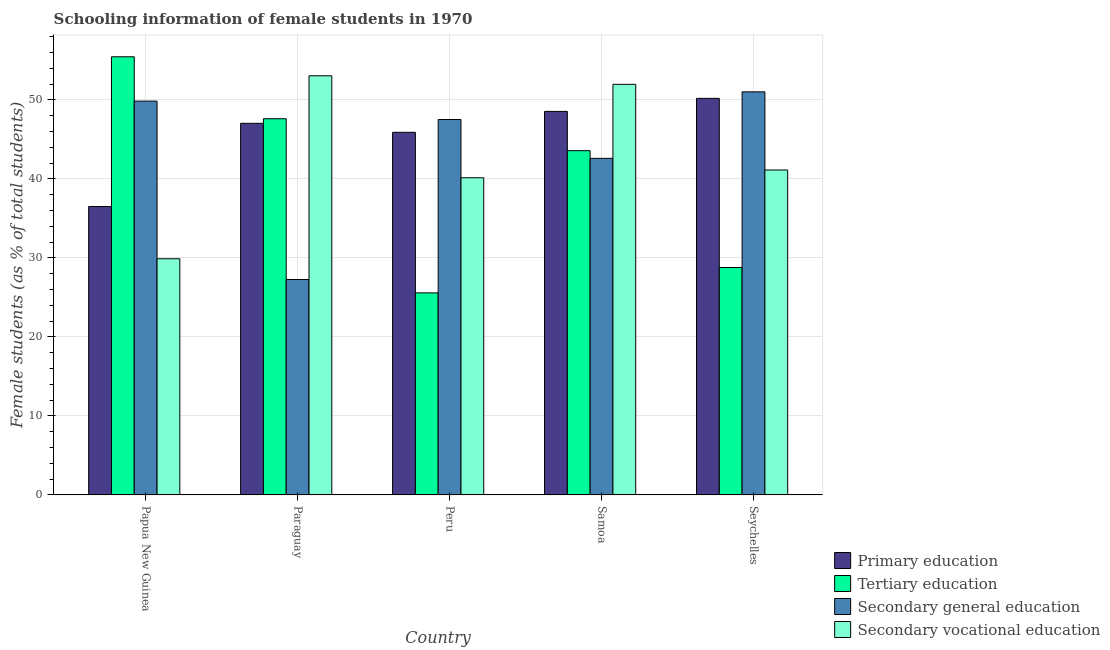How many different coloured bars are there?
Offer a very short reply. 4. Are the number of bars per tick equal to the number of legend labels?
Provide a short and direct response. Yes. Are the number of bars on each tick of the X-axis equal?
Provide a short and direct response. Yes. How many bars are there on the 4th tick from the left?
Provide a succinct answer. 4. What is the label of the 5th group of bars from the left?
Keep it short and to the point. Seychelles. In how many cases, is the number of bars for a given country not equal to the number of legend labels?
Your answer should be very brief. 0. What is the percentage of female students in secondary vocational education in Peru?
Make the answer very short. 40.14. Across all countries, what is the maximum percentage of female students in tertiary education?
Your response must be concise. 55.45. Across all countries, what is the minimum percentage of female students in tertiary education?
Your answer should be compact. 25.57. In which country was the percentage of female students in secondary vocational education maximum?
Offer a very short reply. Paraguay. In which country was the percentage of female students in primary education minimum?
Your answer should be compact. Papua New Guinea. What is the total percentage of female students in primary education in the graph?
Provide a short and direct response. 228.13. What is the difference between the percentage of female students in secondary education in Samoa and that in Seychelles?
Your response must be concise. -8.42. What is the difference between the percentage of female students in tertiary education in Seychelles and the percentage of female students in secondary education in Peru?
Offer a terse response. -18.73. What is the average percentage of female students in secondary vocational education per country?
Provide a short and direct response. 43.23. What is the difference between the percentage of female students in primary education and percentage of female students in secondary education in Seychelles?
Make the answer very short. -0.83. In how many countries, is the percentage of female students in secondary education greater than 56 %?
Offer a very short reply. 0. What is the ratio of the percentage of female students in primary education in Papua New Guinea to that in Paraguay?
Offer a terse response. 0.78. Is the percentage of female students in tertiary education in Papua New Guinea less than that in Paraguay?
Keep it short and to the point. No. What is the difference between the highest and the second highest percentage of female students in primary education?
Provide a succinct answer. 1.65. What is the difference between the highest and the lowest percentage of female students in tertiary education?
Your answer should be very brief. 29.88. In how many countries, is the percentage of female students in secondary education greater than the average percentage of female students in secondary education taken over all countries?
Your answer should be compact. 3. Is it the case that in every country, the sum of the percentage of female students in tertiary education and percentage of female students in secondary education is greater than the sum of percentage of female students in secondary vocational education and percentage of female students in primary education?
Offer a very short reply. Yes. What does the 3rd bar from the left in Peru represents?
Ensure brevity in your answer.  Secondary general education. What does the 3rd bar from the right in Seychelles represents?
Make the answer very short. Tertiary education. Is it the case that in every country, the sum of the percentage of female students in primary education and percentage of female students in tertiary education is greater than the percentage of female students in secondary education?
Keep it short and to the point. Yes. How many bars are there?
Make the answer very short. 20. Are the values on the major ticks of Y-axis written in scientific E-notation?
Your answer should be very brief. No. Does the graph contain any zero values?
Keep it short and to the point. No. Does the graph contain grids?
Provide a succinct answer. Yes. Where does the legend appear in the graph?
Your answer should be very brief. Bottom right. How are the legend labels stacked?
Offer a very short reply. Vertical. What is the title of the graph?
Make the answer very short. Schooling information of female students in 1970. Does "Interest Payments" appear as one of the legend labels in the graph?
Give a very brief answer. No. What is the label or title of the X-axis?
Your answer should be very brief. Country. What is the label or title of the Y-axis?
Your answer should be very brief. Female students (as % of total students). What is the Female students (as % of total students) of Primary education in Papua New Guinea?
Make the answer very short. 36.5. What is the Female students (as % of total students) in Tertiary education in Papua New Guinea?
Offer a very short reply. 55.45. What is the Female students (as % of total students) of Secondary general education in Papua New Guinea?
Provide a succinct answer. 49.84. What is the Female students (as % of total students) of Secondary vocational education in Papua New Guinea?
Your response must be concise. 29.89. What is the Female students (as % of total students) in Primary education in Paraguay?
Offer a very short reply. 47.03. What is the Female students (as % of total students) of Tertiary education in Paraguay?
Your answer should be compact. 47.61. What is the Female students (as % of total students) in Secondary general education in Paraguay?
Offer a very short reply. 27.26. What is the Female students (as % of total students) in Secondary vocational education in Paraguay?
Your answer should be compact. 53.04. What is the Female students (as % of total students) of Primary education in Peru?
Your answer should be very brief. 45.89. What is the Female students (as % of total students) in Tertiary education in Peru?
Keep it short and to the point. 25.57. What is the Female students (as % of total students) in Secondary general education in Peru?
Ensure brevity in your answer.  47.51. What is the Female students (as % of total students) of Secondary vocational education in Peru?
Your response must be concise. 40.14. What is the Female students (as % of total students) in Primary education in Samoa?
Your answer should be very brief. 48.54. What is the Female students (as % of total students) in Tertiary education in Samoa?
Your answer should be very brief. 43.56. What is the Female students (as % of total students) in Secondary general education in Samoa?
Ensure brevity in your answer.  42.59. What is the Female students (as % of total students) of Secondary vocational education in Samoa?
Your answer should be compact. 51.96. What is the Female students (as % of total students) in Primary education in Seychelles?
Provide a succinct answer. 50.18. What is the Female students (as % of total students) in Tertiary education in Seychelles?
Keep it short and to the point. 28.78. What is the Female students (as % of total students) of Secondary general education in Seychelles?
Ensure brevity in your answer.  51.01. What is the Female students (as % of total students) in Secondary vocational education in Seychelles?
Provide a succinct answer. 41.12. Across all countries, what is the maximum Female students (as % of total students) in Primary education?
Your response must be concise. 50.18. Across all countries, what is the maximum Female students (as % of total students) in Tertiary education?
Ensure brevity in your answer.  55.45. Across all countries, what is the maximum Female students (as % of total students) in Secondary general education?
Your answer should be very brief. 51.01. Across all countries, what is the maximum Female students (as % of total students) in Secondary vocational education?
Provide a succinct answer. 53.04. Across all countries, what is the minimum Female students (as % of total students) of Primary education?
Make the answer very short. 36.5. Across all countries, what is the minimum Female students (as % of total students) in Tertiary education?
Your answer should be compact. 25.57. Across all countries, what is the minimum Female students (as % of total students) of Secondary general education?
Keep it short and to the point. 27.26. Across all countries, what is the minimum Female students (as % of total students) in Secondary vocational education?
Ensure brevity in your answer.  29.89. What is the total Female students (as % of total students) in Primary education in the graph?
Ensure brevity in your answer.  228.13. What is the total Female students (as % of total students) of Tertiary education in the graph?
Your answer should be very brief. 200.97. What is the total Female students (as % of total students) of Secondary general education in the graph?
Offer a terse response. 218.21. What is the total Female students (as % of total students) in Secondary vocational education in the graph?
Offer a very short reply. 216.15. What is the difference between the Female students (as % of total students) of Primary education in Papua New Guinea and that in Paraguay?
Keep it short and to the point. -10.53. What is the difference between the Female students (as % of total students) of Tertiary education in Papua New Guinea and that in Paraguay?
Provide a succinct answer. 7.84. What is the difference between the Female students (as % of total students) in Secondary general education in Papua New Guinea and that in Paraguay?
Make the answer very short. 22.57. What is the difference between the Female students (as % of total students) of Secondary vocational education in Papua New Guinea and that in Paraguay?
Offer a very short reply. -23.15. What is the difference between the Female students (as % of total students) of Primary education in Papua New Guinea and that in Peru?
Your response must be concise. -9.39. What is the difference between the Female students (as % of total students) in Tertiary education in Papua New Guinea and that in Peru?
Make the answer very short. 29.88. What is the difference between the Female students (as % of total students) in Secondary general education in Papua New Guinea and that in Peru?
Keep it short and to the point. 2.33. What is the difference between the Female students (as % of total students) in Secondary vocational education in Papua New Guinea and that in Peru?
Make the answer very short. -10.25. What is the difference between the Female students (as % of total students) in Primary education in Papua New Guinea and that in Samoa?
Your answer should be very brief. -12.04. What is the difference between the Female students (as % of total students) in Tertiary education in Papua New Guinea and that in Samoa?
Your answer should be compact. 11.88. What is the difference between the Female students (as % of total students) of Secondary general education in Papua New Guinea and that in Samoa?
Provide a short and direct response. 7.24. What is the difference between the Female students (as % of total students) in Secondary vocational education in Papua New Guinea and that in Samoa?
Make the answer very short. -22.07. What is the difference between the Female students (as % of total students) in Primary education in Papua New Guinea and that in Seychelles?
Your answer should be very brief. -13.69. What is the difference between the Female students (as % of total students) of Tertiary education in Papua New Guinea and that in Seychelles?
Ensure brevity in your answer.  26.67. What is the difference between the Female students (as % of total students) in Secondary general education in Papua New Guinea and that in Seychelles?
Ensure brevity in your answer.  -1.17. What is the difference between the Female students (as % of total students) in Secondary vocational education in Papua New Guinea and that in Seychelles?
Offer a very short reply. -11.23. What is the difference between the Female students (as % of total students) in Primary education in Paraguay and that in Peru?
Offer a very short reply. 1.14. What is the difference between the Female students (as % of total students) in Tertiary education in Paraguay and that in Peru?
Provide a short and direct response. 22.04. What is the difference between the Female students (as % of total students) of Secondary general education in Paraguay and that in Peru?
Provide a short and direct response. -20.24. What is the difference between the Female students (as % of total students) of Secondary vocational education in Paraguay and that in Peru?
Keep it short and to the point. 12.9. What is the difference between the Female students (as % of total students) of Primary education in Paraguay and that in Samoa?
Give a very brief answer. -1.51. What is the difference between the Female students (as % of total students) in Tertiary education in Paraguay and that in Samoa?
Ensure brevity in your answer.  4.04. What is the difference between the Female students (as % of total students) of Secondary general education in Paraguay and that in Samoa?
Your response must be concise. -15.33. What is the difference between the Female students (as % of total students) of Secondary vocational education in Paraguay and that in Samoa?
Offer a very short reply. 1.08. What is the difference between the Female students (as % of total students) in Primary education in Paraguay and that in Seychelles?
Your answer should be compact. -3.16. What is the difference between the Female students (as % of total students) of Tertiary education in Paraguay and that in Seychelles?
Give a very brief answer. 18.83. What is the difference between the Female students (as % of total students) of Secondary general education in Paraguay and that in Seychelles?
Give a very brief answer. -23.75. What is the difference between the Female students (as % of total students) in Secondary vocational education in Paraguay and that in Seychelles?
Offer a very short reply. 11.92. What is the difference between the Female students (as % of total students) in Primary education in Peru and that in Samoa?
Ensure brevity in your answer.  -2.65. What is the difference between the Female students (as % of total students) of Tertiary education in Peru and that in Samoa?
Your response must be concise. -17.99. What is the difference between the Female students (as % of total students) in Secondary general education in Peru and that in Samoa?
Provide a succinct answer. 4.92. What is the difference between the Female students (as % of total students) of Secondary vocational education in Peru and that in Samoa?
Provide a short and direct response. -11.82. What is the difference between the Female students (as % of total students) of Primary education in Peru and that in Seychelles?
Provide a short and direct response. -4.29. What is the difference between the Female students (as % of total students) in Tertiary education in Peru and that in Seychelles?
Keep it short and to the point. -3.21. What is the difference between the Female students (as % of total students) of Secondary general education in Peru and that in Seychelles?
Ensure brevity in your answer.  -3.5. What is the difference between the Female students (as % of total students) of Secondary vocational education in Peru and that in Seychelles?
Your response must be concise. -0.98. What is the difference between the Female students (as % of total students) of Primary education in Samoa and that in Seychelles?
Make the answer very short. -1.65. What is the difference between the Female students (as % of total students) in Tertiary education in Samoa and that in Seychelles?
Keep it short and to the point. 14.78. What is the difference between the Female students (as % of total students) of Secondary general education in Samoa and that in Seychelles?
Provide a short and direct response. -8.42. What is the difference between the Female students (as % of total students) of Secondary vocational education in Samoa and that in Seychelles?
Your answer should be compact. 10.84. What is the difference between the Female students (as % of total students) of Primary education in Papua New Guinea and the Female students (as % of total students) of Tertiary education in Paraguay?
Your answer should be compact. -11.11. What is the difference between the Female students (as % of total students) of Primary education in Papua New Guinea and the Female students (as % of total students) of Secondary general education in Paraguay?
Your answer should be compact. 9.23. What is the difference between the Female students (as % of total students) of Primary education in Papua New Guinea and the Female students (as % of total students) of Secondary vocational education in Paraguay?
Your answer should be very brief. -16.54. What is the difference between the Female students (as % of total students) in Tertiary education in Papua New Guinea and the Female students (as % of total students) in Secondary general education in Paraguay?
Your answer should be very brief. 28.18. What is the difference between the Female students (as % of total students) in Tertiary education in Papua New Guinea and the Female students (as % of total students) in Secondary vocational education in Paraguay?
Your answer should be very brief. 2.41. What is the difference between the Female students (as % of total students) in Secondary general education in Papua New Guinea and the Female students (as % of total students) in Secondary vocational education in Paraguay?
Keep it short and to the point. -3.2. What is the difference between the Female students (as % of total students) in Primary education in Papua New Guinea and the Female students (as % of total students) in Tertiary education in Peru?
Your answer should be compact. 10.93. What is the difference between the Female students (as % of total students) of Primary education in Papua New Guinea and the Female students (as % of total students) of Secondary general education in Peru?
Provide a short and direct response. -11.01. What is the difference between the Female students (as % of total students) in Primary education in Papua New Guinea and the Female students (as % of total students) in Secondary vocational education in Peru?
Offer a very short reply. -3.64. What is the difference between the Female students (as % of total students) in Tertiary education in Papua New Guinea and the Female students (as % of total students) in Secondary general education in Peru?
Give a very brief answer. 7.94. What is the difference between the Female students (as % of total students) of Tertiary education in Papua New Guinea and the Female students (as % of total students) of Secondary vocational education in Peru?
Your response must be concise. 15.31. What is the difference between the Female students (as % of total students) of Secondary general education in Papua New Guinea and the Female students (as % of total students) of Secondary vocational education in Peru?
Make the answer very short. 9.7. What is the difference between the Female students (as % of total students) of Primary education in Papua New Guinea and the Female students (as % of total students) of Tertiary education in Samoa?
Offer a terse response. -7.07. What is the difference between the Female students (as % of total students) in Primary education in Papua New Guinea and the Female students (as % of total students) in Secondary general education in Samoa?
Keep it short and to the point. -6.1. What is the difference between the Female students (as % of total students) of Primary education in Papua New Guinea and the Female students (as % of total students) of Secondary vocational education in Samoa?
Give a very brief answer. -15.46. What is the difference between the Female students (as % of total students) of Tertiary education in Papua New Guinea and the Female students (as % of total students) of Secondary general education in Samoa?
Offer a terse response. 12.85. What is the difference between the Female students (as % of total students) in Tertiary education in Papua New Guinea and the Female students (as % of total students) in Secondary vocational education in Samoa?
Provide a succinct answer. 3.49. What is the difference between the Female students (as % of total students) of Secondary general education in Papua New Guinea and the Female students (as % of total students) of Secondary vocational education in Samoa?
Give a very brief answer. -2.12. What is the difference between the Female students (as % of total students) of Primary education in Papua New Guinea and the Female students (as % of total students) of Tertiary education in Seychelles?
Provide a succinct answer. 7.72. What is the difference between the Female students (as % of total students) in Primary education in Papua New Guinea and the Female students (as % of total students) in Secondary general education in Seychelles?
Give a very brief answer. -14.51. What is the difference between the Female students (as % of total students) of Primary education in Papua New Guinea and the Female students (as % of total students) of Secondary vocational education in Seychelles?
Provide a short and direct response. -4.62. What is the difference between the Female students (as % of total students) in Tertiary education in Papua New Guinea and the Female students (as % of total students) in Secondary general education in Seychelles?
Provide a succinct answer. 4.44. What is the difference between the Female students (as % of total students) of Tertiary education in Papua New Guinea and the Female students (as % of total students) of Secondary vocational education in Seychelles?
Your response must be concise. 14.33. What is the difference between the Female students (as % of total students) of Secondary general education in Papua New Guinea and the Female students (as % of total students) of Secondary vocational education in Seychelles?
Your answer should be compact. 8.72. What is the difference between the Female students (as % of total students) in Primary education in Paraguay and the Female students (as % of total students) in Tertiary education in Peru?
Provide a short and direct response. 21.46. What is the difference between the Female students (as % of total students) in Primary education in Paraguay and the Female students (as % of total students) in Secondary general education in Peru?
Offer a very short reply. -0.48. What is the difference between the Female students (as % of total students) of Primary education in Paraguay and the Female students (as % of total students) of Secondary vocational education in Peru?
Your response must be concise. 6.89. What is the difference between the Female students (as % of total students) in Tertiary education in Paraguay and the Female students (as % of total students) in Secondary general education in Peru?
Provide a succinct answer. 0.1. What is the difference between the Female students (as % of total students) of Tertiary education in Paraguay and the Female students (as % of total students) of Secondary vocational education in Peru?
Your response must be concise. 7.47. What is the difference between the Female students (as % of total students) in Secondary general education in Paraguay and the Female students (as % of total students) in Secondary vocational education in Peru?
Make the answer very short. -12.87. What is the difference between the Female students (as % of total students) of Primary education in Paraguay and the Female students (as % of total students) of Tertiary education in Samoa?
Provide a succinct answer. 3.46. What is the difference between the Female students (as % of total students) in Primary education in Paraguay and the Female students (as % of total students) in Secondary general education in Samoa?
Your response must be concise. 4.43. What is the difference between the Female students (as % of total students) of Primary education in Paraguay and the Female students (as % of total students) of Secondary vocational education in Samoa?
Provide a short and direct response. -4.93. What is the difference between the Female students (as % of total students) of Tertiary education in Paraguay and the Female students (as % of total students) of Secondary general education in Samoa?
Ensure brevity in your answer.  5.02. What is the difference between the Female students (as % of total students) of Tertiary education in Paraguay and the Female students (as % of total students) of Secondary vocational education in Samoa?
Offer a very short reply. -4.35. What is the difference between the Female students (as % of total students) in Secondary general education in Paraguay and the Female students (as % of total students) in Secondary vocational education in Samoa?
Ensure brevity in your answer.  -24.7. What is the difference between the Female students (as % of total students) in Primary education in Paraguay and the Female students (as % of total students) in Tertiary education in Seychelles?
Your answer should be very brief. 18.25. What is the difference between the Female students (as % of total students) in Primary education in Paraguay and the Female students (as % of total students) in Secondary general education in Seychelles?
Offer a terse response. -3.98. What is the difference between the Female students (as % of total students) of Primary education in Paraguay and the Female students (as % of total students) of Secondary vocational education in Seychelles?
Provide a succinct answer. 5.91. What is the difference between the Female students (as % of total students) in Tertiary education in Paraguay and the Female students (as % of total students) in Secondary general education in Seychelles?
Offer a terse response. -3.4. What is the difference between the Female students (as % of total students) of Tertiary education in Paraguay and the Female students (as % of total students) of Secondary vocational education in Seychelles?
Your answer should be very brief. 6.49. What is the difference between the Female students (as % of total students) of Secondary general education in Paraguay and the Female students (as % of total students) of Secondary vocational education in Seychelles?
Keep it short and to the point. -13.86. What is the difference between the Female students (as % of total students) in Primary education in Peru and the Female students (as % of total students) in Tertiary education in Samoa?
Your answer should be very brief. 2.32. What is the difference between the Female students (as % of total students) in Primary education in Peru and the Female students (as % of total students) in Secondary general education in Samoa?
Provide a succinct answer. 3.3. What is the difference between the Female students (as % of total students) in Primary education in Peru and the Female students (as % of total students) in Secondary vocational education in Samoa?
Your response must be concise. -6.07. What is the difference between the Female students (as % of total students) of Tertiary education in Peru and the Female students (as % of total students) of Secondary general education in Samoa?
Your answer should be very brief. -17.02. What is the difference between the Female students (as % of total students) in Tertiary education in Peru and the Female students (as % of total students) in Secondary vocational education in Samoa?
Provide a short and direct response. -26.39. What is the difference between the Female students (as % of total students) of Secondary general education in Peru and the Female students (as % of total students) of Secondary vocational education in Samoa?
Offer a very short reply. -4.45. What is the difference between the Female students (as % of total students) of Primary education in Peru and the Female students (as % of total students) of Tertiary education in Seychelles?
Provide a succinct answer. 17.11. What is the difference between the Female students (as % of total students) in Primary education in Peru and the Female students (as % of total students) in Secondary general education in Seychelles?
Ensure brevity in your answer.  -5.12. What is the difference between the Female students (as % of total students) of Primary education in Peru and the Female students (as % of total students) of Secondary vocational education in Seychelles?
Offer a very short reply. 4.77. What is the difference between the Female students (as % of total students) in Tertiary education in Peru and the Female students (as % of total students) in Secondary general education in Seychelles?
Keep it short and to the point. -25.44. What is the difference between the Female students (as % of total students) in Tertiary education in Peru and the Female students (as % of total students) in Secondary vocational education in Seychelles?
Ensure brevity in your answer.  -15.55. What is the difference between the Female students (as % of total students) of Secondary general education in Peru and the Female students (as % of total students) of Secondary vocational education in Seychelles?
Offer a terse response. 6.39. What is the difference between the Female students (as % of total students) in Primary education in Samoa and the Female students (as % of total students) in Tertiary education in Seychelles?
Keep it short and to the point. 19.76. What is the difference between the Female students (as % of total students) in Primary education in Samoa and the Female students (as % of total students) in Secondary general education in Seychelles?
Make the answer very short. -2.47. What is the difference between the Female students (as % of total students) in Primary education in Samoa and the Female students (as % of total students) in Secondary vocational education in Seychelles?
Offer a very short reply. 7.42. What is the difference between the Female students (as % of total students) of Tertiary education in Samoa and the Female students (as % of total students) of Secondary general education in Seychelles?
Give a very brief answer. -7.44. What is the difference between the Female students (as % of total students) of Tertiary education in Samoa and the Female students (as % of total students) of Secondary vocational education in Seychelles?
Your answer should be compact. 2.44. What is the difference between the Female students (as % of total students) in Secondary general education in Samoa and the Female students (as % of total students) in Secondary vocational education in Seychelles?
Provide a succinct answer. 1.47. What is the average Female students (as % of total students) of Primary education per country?
Keep it short and to the point. 45.63. What is the average Female students (as % of total students) in Tertiary education per country?
Provide a short and direct response. 40.19. What is the average Female students (as % of total students) of Secondary general education per country?
Offer a terse response. 43.64. What is the average Female students (as % of total students) in Secondary vocational education per country?
Your response must be concise. 43.23. What is the difference between the Female students (as % of total students) in Primary education and Female students (as % of total students) in Tertiary education in Papua New Guinea?
Your answer should be compact. -18.95. What is the difference between the Female students (as % of total students) in Primary education and Female students (as % of total students) in Secondary general education in Papua New Guinea?
Ensure brevity in your answer.  -13.34. What is the difference between the Female students (as % of total students) in Primary education and Female students (as % of total students) in Secondary vocational education in Papua New Guinea?
Your answer should be compact. 6.61. What is the difference between the Female students (as % of total students) of Tertiary education and Female students (as % of total students) of Secondary general education in Papua New Guinea?
Your answer should be compact. 5.61. What is the difference between the Female students (as % of total students) of Tertiary education and Female students (as % of total students) of Secondary vocational education in Papua New Guinea?
Your answer should be compact. 25.56. What is the difference between the Female students (as % of total students) in Secondary general education and Female students (as % of total students) in Secondary vocational education in Papua New Guinea?
Make the answer very short. 19.95. What is the difference between the Female students (as % of total students) of Primary education and Female students (as % of total students) of Tertiary education in Paraguay?
Offer a terse response. -0.58. What is the difference between the Female students (as % of total students) in Primary education and Female students (as % of total students) in Secondary general education in Paraguay?
Ensure brevity in your answer.  19.76. What is the difference between the Female students (as % of total students) in Primary education and Female students (as % of total students) in Secondary vocational education in Paraguay?
Your answer should be very brief. -6.01. What is the difference between the Female students (as % of total students) in Tertiary education and Female students (as % of total students) in Secondary general education in Paraguay?
Keep it short and to the point. 20.34. What is the difference between the Female students (as % of total students) of Tertiary education and Female students (as % of total students) of Secondary vocational education in Paraguay?
Make the answer very short. -5.43. What is the difference between the Female students (as % of total students) in Secondary general education and Female students (as % of total students) in Secondary vocational education in Paraguay?
Your response must be concise. -25.78. What is the difference between the Female students (as % of total students) of Primary education and Female students (as % of total students) of Tertiary education in Peru?
Give a very brief answer. 20.32. What is the difference between the Female students (as % of total students) of Primary education and Female students (as % of total students) of Secondary general education in Peru?
Keep it short and to the point. -1.62. What is the difference between the Female students (as % of total students) in Primary education and Female students (as % of total students) in Secondary vocational education in Peru?
Your answer should be very brief. 5.75. What is the difference between the Female students (as % of total students) of Tertiary education and Female students (as % of total students) of Secondary general education in Peru?
Provide a succinct answer. -21.94. What is the difference between the Female students (as % of total students) of Tertiary education and Female students (as % of total students) of Secondary vocational education in Peru?
Give a very brief answer. -14.57. What is the difference between the Female students (as % of total students) of Secondary general education and Female students (as % of total students) of Secondary vocational education in Peru?
Your response must be concise. 7.37. What is the difference between the Female students (as % of total students) of Primary education and Female students (as % of total students) of Tertiary education in Samoa?
Provide a succinct answer. 4.97. What is the difference between the Female students (as % of total students) in Primary education and Female students (as % of total students) in Secondary general education in Samoa?
Provide a succinct answer. 5.94. What is the difference between the Female students (as % of total students) in Primary education and Female students (as % of total students) in Secondary vocational education in Samoa?
Provide a short and direct response. -3.42. What is the difference between the Female students (as % of total students) in Tertiary education and Female students (as % of total students) in Secondary general education in Samoa?
Your response must be concise. 0.97. What is the difference between the Female students (as % of total students) in Tertiary education and Female students (as % of total students) in Secondary vocational education in Samoa?
Provide a succinct answer. -8.4. What is the difference between the Female students (as % of total students) in Secondary general education and Female students (as % of total students) in Secondary vocational education in Samoa?
Keep it short and to the point. -9.37. What is the difference between the Female students (as % of total students) of Primary education and Female students (as % of total students) of Tertiary education in Seychelles?
Your answer should be very brief. 21.4. What is the difference between the Female students (as % of total students) in Primary education and Female students (as % of total students) in Secondary general education in Seychelles?
Your answer should be compact. -0.83. What is the difference between the Female students (as % of total students) of Primary education and Female students (as % of total students) of Secondary vocational education in Seychelles?
Provide a succinct answer. 9.06. What is the difference between the Female students (as % of total students) of Tertiary education and Female students (as % of total students) of Secondary general education in Seychelles?
Give a very brief answer. -22.23. What is the difference between the Female students (as % of total students) of Tertiary education and Female students (as % of total students) of Secondary vocational education in Seychelles?
Provide a succinct answer. -12.34. What is the difference between the Female students (as % of total students) in Secondary general education and Female students (as % of total students) in Secondary vocational education in Seychelles?
Offer a very short reply. 9.89. What is the ratio of the Female students (as % of total students) of Primary education in Papua New Guinea to that in Paraguay?
Your answer should be compact. 0.78. What is the ratio of the Female students (as % of total students) in Tertiary education in Papua New Guinea to that in Paraguay?
Give a very brief answer. 1.16. What is the ratio of the Female students (as % of total students) in Secondary general education in Papua New Guinea to that in Paraguay?
Keep it short and to the point. 1.83. What is the ratio of the Female students (as % of total students) in Secondary vocational education in Papua New Guinea to that in Paraguay?
Keep it short and to the point. 0.56. What is the ratio of the Female students (as % of total students) in Primary education in Papua New Guinea to that in Peru?
Make the answer very short. 0.8. What is the ratio of the Female students (as % of total students) of Tertiary education in Papua New Guinea to that in Peru?
Offer a very short reply. 2.17. What is the ratio of the Female students (as % of total students) of Secondary general education in Papua New Guinea to that in Peru?
Provide a short and direct response. 1.05. What is the ratio of the Female students (as % of total students) in Secondary vocational education in Papua New Guinea to that in Peru?
Provide a short and direct response. 0.74. What is the ratio of the Female students (as % of total students) in Primary education in Papua New Guinea to that in Samoa?
Ensure brevity in your answer.  0.75. What is the ratio of the Female students (as % of total students) in Tertiary education in Papua New Guinea to that in Samoa?
Provide a short and direct response. 1.27. What is the ratio of the Female students (as % of total students) in Secondary general education in Papua New Guinea to that in Samoa?
Your answer should be very brief. 1.17. What is the ratio of the Female students (as % of total students) in Secondary vocational education in Papua New Guinea to that in Samoa?
Your answer should be compact. 0.58. What is the ratio of the Female students (as % of total students) in Primary education in Papua New Guinea to that in Seychelles?
Your response must be concise. 0.73. What is the ratio of the Female students (as % of total students) in Tertiary education in Papua New Guinea to that in Seychelles?
Provide a succinct answer. 1.93. What is the ratio of the Female students (as % of total students) of Secondary general education in Papua New Guinea to that in Seychelles?
Offer a very short reply. 0.98. What is the ratio of the Female students (as % of total students) in Secondary vocational education in Papua New Guinea to that in Seychelles?
Your response must be concise. 0.73. What is the ratio of the Female students (as % of total students) in Primary education in Paraguay to that in Peru?
Keep it short and to the point. 1.02. What is the ratio of the Female students (as % of total students) of Tertiary education in Paraguay to that in Peru?
Ensure brevity in your answer.  1.86. What is the ratio of the Female students (as % of total students) in Secondary general education in Paraguay to that in Peru?
Your answer should be very brief. 0.57. What is the ratio of the Female students (as % of total students) of Secondary vocational education in Paraguay to that in Peru?
Your answer should be compact. 1.32. What is the ratio of the Female students (as % of total students) in Primary education in Paraguay to that in Samoa?
Your response must be concise. 0.97. What is the ratio of the Female students (as % of total students) in Tertiary education in Paraguay to that in Samoa?
Provide a succinct answer. 1.09. What is the ratio of the Female students (as % of total students) in Secondary general education in Paraguay to that in Samoa?
Your answer should be very brief. 0.64. What is the ratio of the Female students (as % of total students) in Secondary vocational education in Paraguay to that in Samoa?
Your answer should be very brief. 1.02. What is the ratio of the Female students (as % of total students) in Primary education in Paraguay to that in Seychelles?
Provide a succinct answer. 0.94. What is the ratio of the Female students (as % of total students) in Tertiary education in Paraguay to that in Seychelles?
Ensure brevity in your answer.  1.65. What is the ratio of the Female students (as % of total students) in Secondary general education in Paraguay to that in Seychelles?
Provide a short and direct response. 0.53. What is the ratio of the Female students (as % of total students) of Secondary vocational education in Paraguay to that in Seychelles?
Your answer should be very brief. 1.29. What is the ratio of the Female students (as % of total students) of Primary education in Peru to that in Samoa?
Offer a very short reply. 0.95. What is the ratio of the Female students (as % of total students) of Tertiary education in Peru to that in Samoa?
Provide a short and direct response. 0.59. What is the ratio of the Female students (as % of total students) of Secondary general education in Peru to that in Samoa?
Provide a succinct answer. 1.12. What is the ratio of the Female students (as % of total students) in Secondary vocational education in Peru to that in Samoa?
Keep it short and to the point. 0.77. What is the ratio of the Female students (as % of total students) in Primary education in Peru to that in Seychelles?
Your answer should be compact. 0.91. What is the ratio of the Female students (as % of total students) in Tertiary education in Peru to that in Seychelles?
Make the answer very short. 0.89. What is the ratio of the Female students (as % of total students) in Secondary general education in Peru to that in Seychelles?
Your answer should be very brief. 0.93. What is the ratio of the Female students (as % of total students) of Secondary vocational education in Peru to that in Seychelles?
Offer a terse response. 0.98. What is the ratio of the Female students (as % of total students) of Primary education in Samoa to that in Seychelles?
Make the answer very short. 0.97. What is the ratio of the Female students (as % of total students) of Tertiary education in Samoa to that in Seychelles?
Keep it short and to the point. 1.51. What is the ratio of the Female students (as % of total students) in Secondary general education in Samoa to that in Seychelles?
Keep it short and to the point. 0.83. What is the ratio of the Female students (as % of total students) in Secondary vocational education in Samoa to that in Seychelles?
Make the answer very short. 1.26. What is the difference between the highest and the second highest Female students (as % of total students) of Primary education?
Ensure brevity in your answer.  1.65. What is the difference between the highest and the second highest Female students (as % of total students) in Tertiary education?
Offer a terse response. 7.84. What is the difference between the highest and the second highest Female students (as % of total students) in Secondary general education?
Your answer should be compact. 1.17. What is the difference between the highest and the second highest Female students (as % of total students) in Secondary vocational education?
Provide a succinct answer. 1.08. What is the difference between the highest and the lowest Female students (as % of total students) in Primary education?
Give a very brief answer. 13.69. What is the difference between the highest and the lowest Female students (as % of total students) of Tertiary education?
Provide a succinct answer. 29.88. What is the difference between the highest and the lowest Female students (as % of total students) of Secondary general education?
Give a very brief answer. 23.75. What is the difference between the highest and the lowest Female students (as % of total students) in Secondary vocational education?
Offer a very short reply. 23.15. 